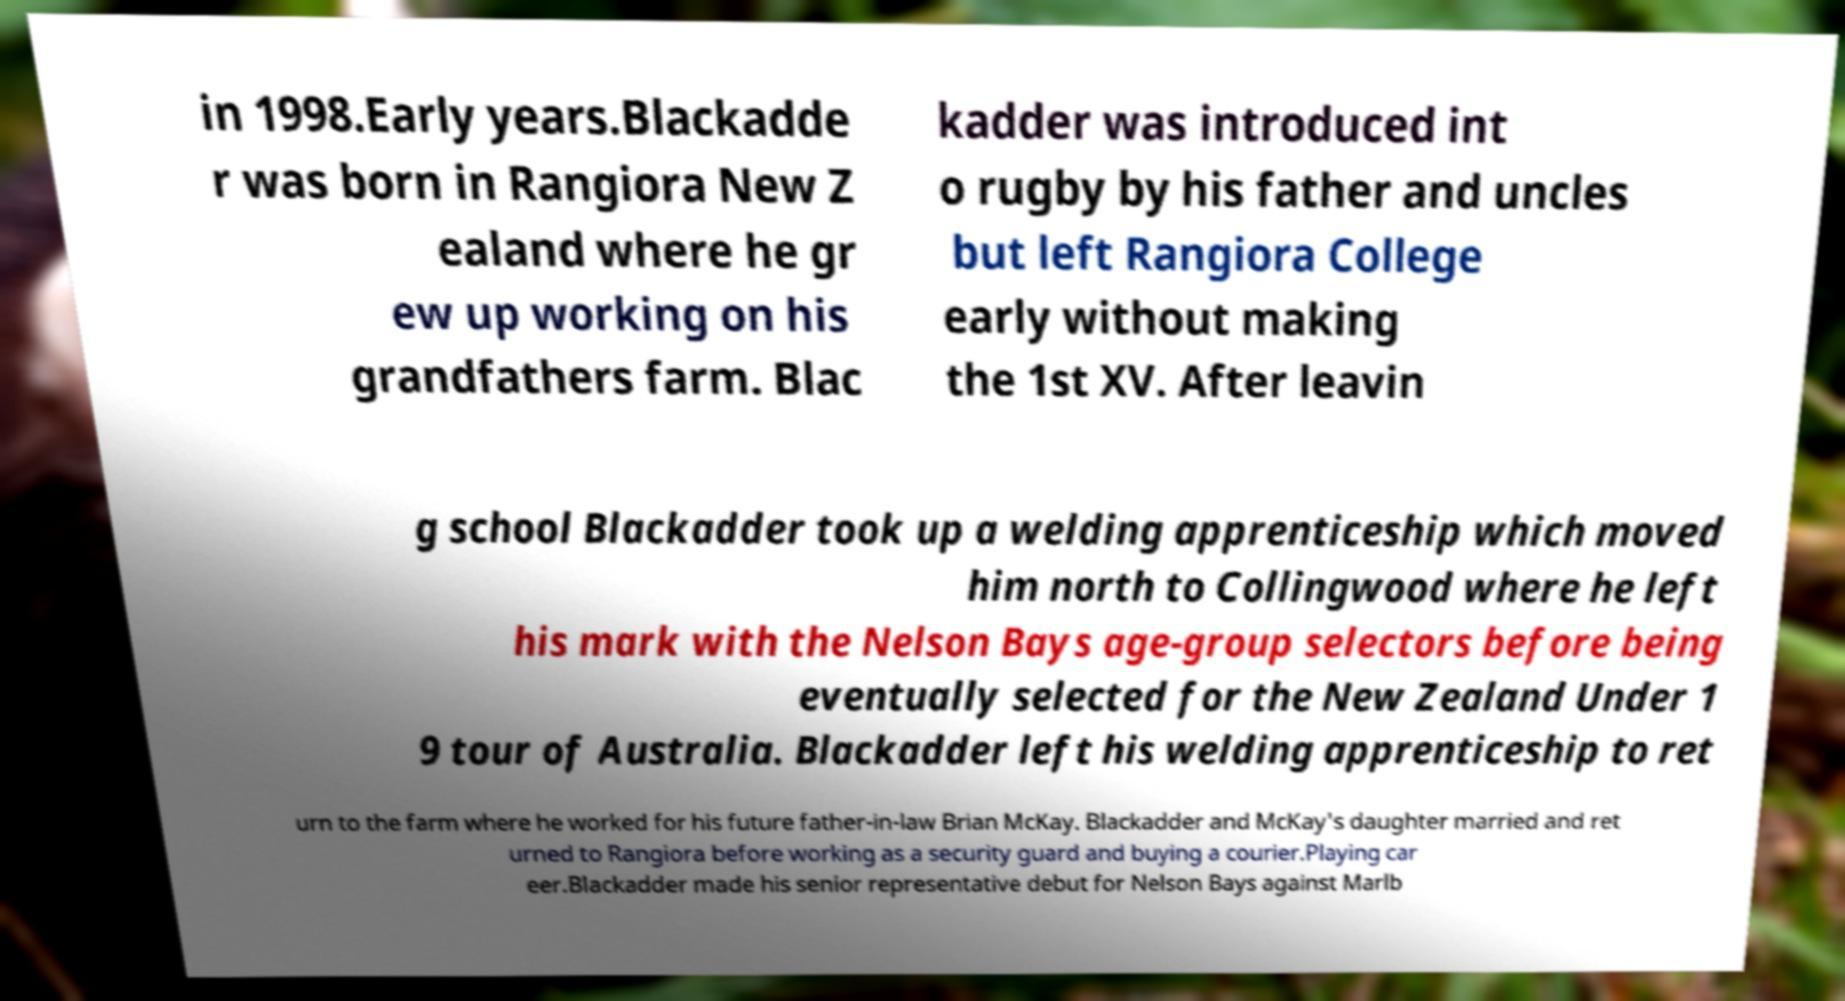What messages or text are displayed in this image? I need them in a readable, typed format. in 1998.Early years.Blackadde r was born in Rangiora New Z ealand where he gr ew up working on his grandfathers farm. Blac kadder was introduced int o rugby by his father and uncles but left Rangiora College early without making the 1st XV. After leavin g school Blackadder took up a welding apprenticeship which moved him north to Collingwood where he left his mark with the Nelson Bays age-group selectors before being eventually selected for the New Zealand Under 1 9 tour of Australia. Blackadder left his welding apprenticeship to ret urn to the farm where he worked for his future father-in-law Brian McKay. Blackadder and McKay's daughter married and ret urned to Rangiora before working as a security guard and buying a courier.Playing car eer.Blackadder made his senior representative debut for Nelson Bays against Marlb 